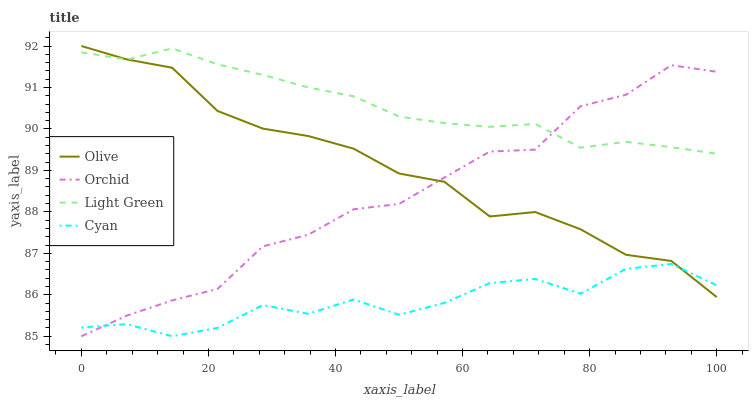Does Cyan have the minimum area under the curve?
Answer yes or no. Yes. Does Light Green have the maximum area under the curve?
Answer yes or no. Yes. Does Light Green have the minimum area under the curve?
Answer yes or no. No. Does Cyan have the maximum area under the curve?
Answer yes or no. No. Is Light Green the smoothest?
Answer yes or no. Yes. Is Cyan the roughest?
Answer yes or no. Yes. Is Cyan the smoothest?
Answer yes or no. No. Is Light Green the roughest?
Answer yes or no. No. Does Cyan have the lowest value?
Answer yes or no. Yes. Does Light Green have the lowest value?
Answer yes or no. No. Does Olive have the highest value?
Answer yes or no. Yes. Does Light Green have the highest value?
Answer yes or no. No. Is Cyan less than Light Green?
Answer yes or no. Yes. Is Light Green greater than Cyan?
Answer yes or no. Yes. Does Light Green intersect Olive?
Answer yes or no. Yes. Is Light Green less than Olive?
Answer yes or no. No. Is Light Green greater than Olive?
Answer yes or no. No. Does Cyan intersect Light Green?
Answer yes or no. No. 